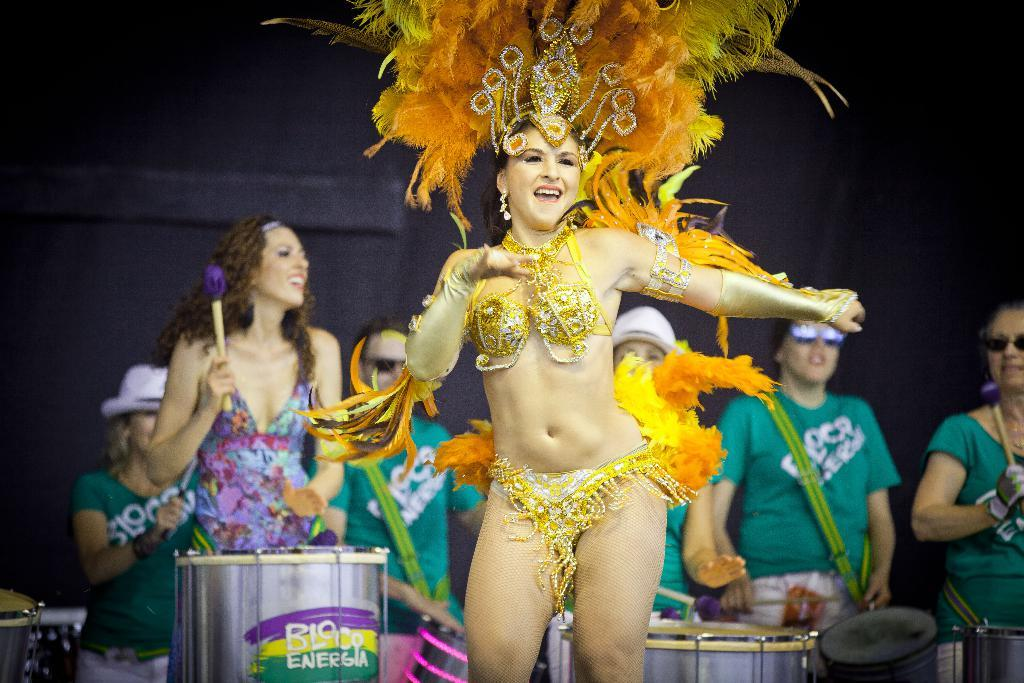How many people are in the image? There are people standing in the image. Can you describe any specific details about the people in the image? One person is wearing a costume. What type of horse can be seen in the image? There is no horse present in the image; it features people, with one of them wearing a costume. 